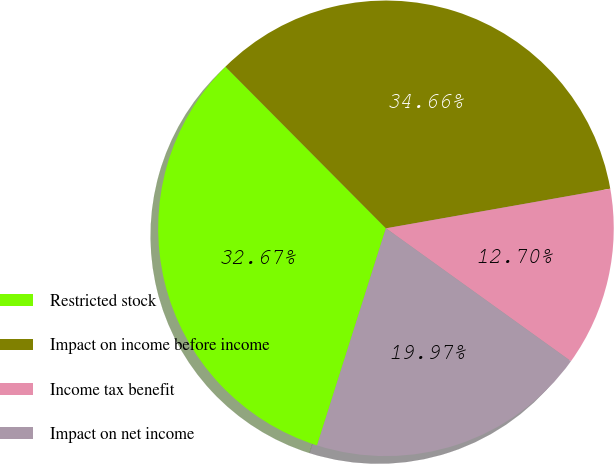Convert chart. <chart><loc_0><loc_0><loc_500><loc_500><pie_chart><fcel>Restricted stock<fcel>Impact on income before income<fcel>Income tax benefit<fcel>Impact on net income<nl><fcel>32.67%<fcel>34.66%<fcel>12.7%<fcel>19.97%<nl></chart> 